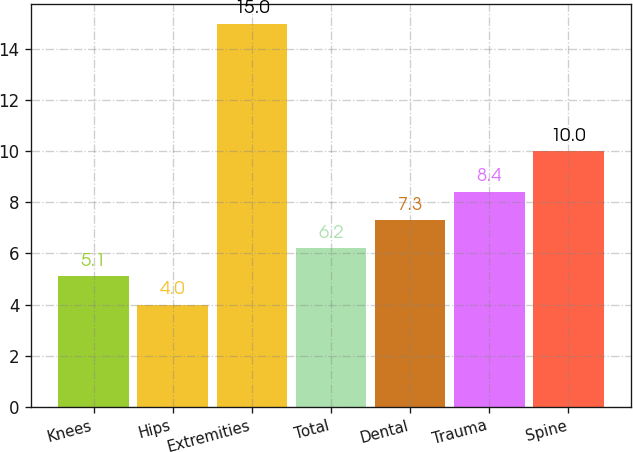Convert chart to OTSL. <chart><loc_0><loc_0><loc_500><loc_500><bar_chart><fcel>Knees<fcel>Hips<fcel>Extremities<fcel>Total<fcel>Dental<fcel>Trauma<fcel>Spine<nl><fcel>5.1<fcel>4<fcel>15<fcel>6.2<fcel>7.3<fcel>8.4<fcel>10<nl></chart> 